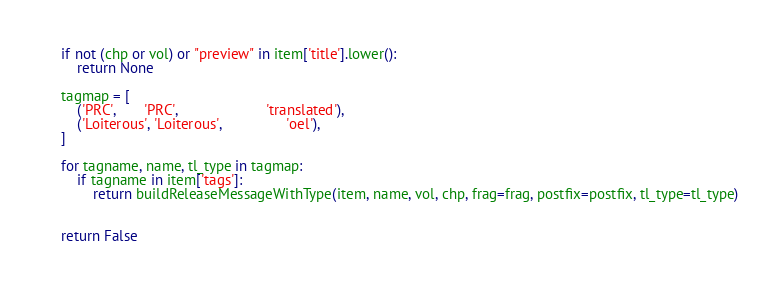<code> <loc_0><loc_0><loc_500><loc_500><_Python_>	if not (chp or vol) or "preview" in item['title'].lower():
		return None

	tagmap = [
		('PRC',       'PRC',                      'translated'),
		('Loiterous', 'Loiterous',                'oel'),
	]

	for tagname, name, tl_type in tagmap:
		if tagname in item['tags']:
			return buildReleaseMessageWithType(item, name, vol, chp, frag=frag, postfix=postfix, tl_type=tl_type)


	return False
	</code> 